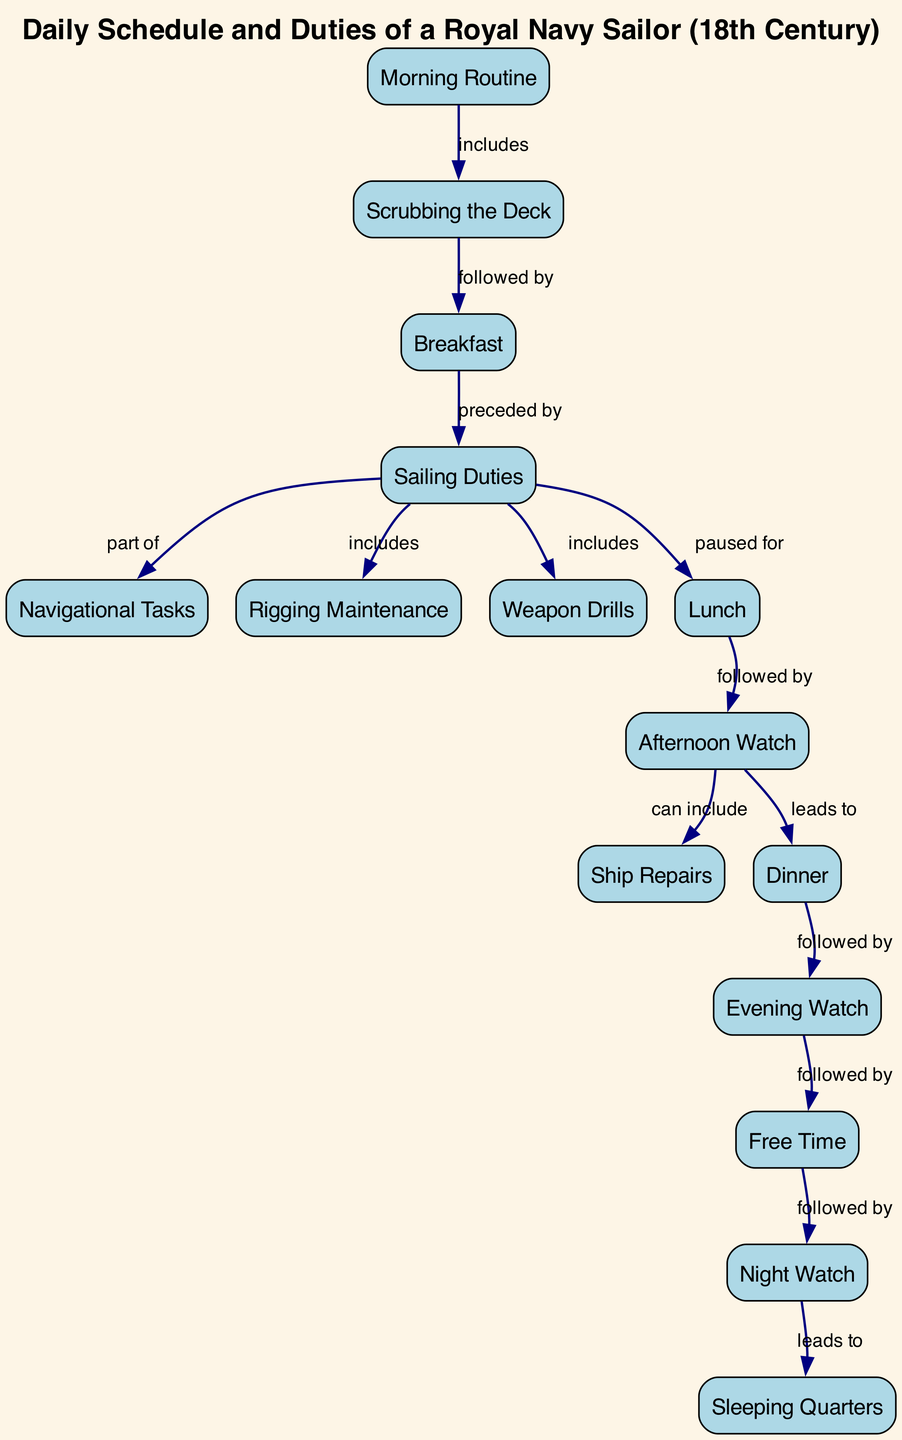What is the first activity in the daily schedule? The diagram indicates that the first activity is "Morning Routine," which is the initial node in the flow.
Answer: Morning Routine How many total nodes are present in the diagram? By counting the nodes listed, there are a total of 15 distinct activities included in the diagram.
Answer: 15 What does "Scrubbing the Deck" lead to? According to the edge relationship from "Scrubbing the Deck," it is followed by "Breakfast," indicating a direct sequence.
Answer: Breakfast Which activity comes after "Lunch"? The diagram shows that "Lunch" is followed by "Afternoon Watch," indicating the scheduling of daily duties.
Answer: Afternoon Watch What is included in "Sailing Duties"? The diagram specifies that "Sailing Duties" includes "Rigging Maintenance" and "Weapon Drills," showing the responsibilities entailed within this activity.
Answer: Rigging Maintenance, Weapon Drills What are the last two activities in the schedule and how do they relate? The final activities are "Night Watch" and "Sleeping Quarters," where "Night Watch" leads directly to "Sleeping Quarters," completing the daily cycle.
Answer: Night Watch, Sleeping Quarters Which activity directly precedes "Dinner"? The diagram indicates that "Dinner" is preceded by "Ship Repairs," which shows the flow of activities leading up to mealtime.
Answer: Ship Repairs How are "Sailing Duties" related to "Navigational Tasks"? "Sailing Duties" is part of the broader category of tasks that includes "Navigational Tasks", linking these critical responsibilities in the sailor's schedule.
Answer: part of What is the total number of edges connecting the activities? By counting the edges in the diagram, there are a total of 14 connections illustrating the relationships between various activities.
Answer: 14 